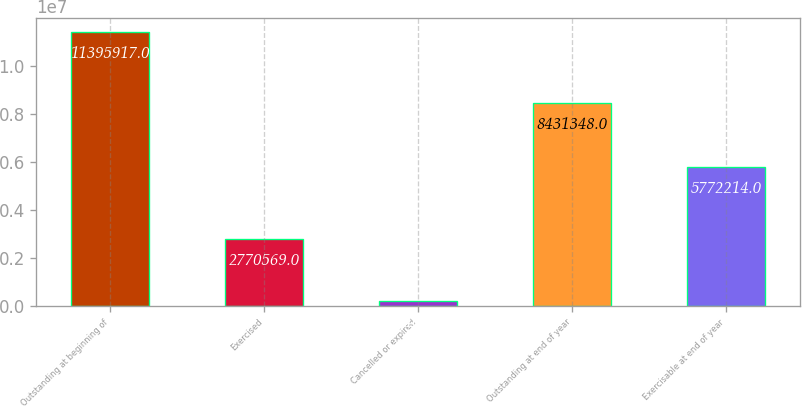<chart> <loc_0><loc_0><loc_500><loc_500><bar_chart><fcel>Outstanding at beginning of<fcel>Exercised<fcel>Cancelled or expired<fcel>Outstanding at end of year<fcel>Exercisable at end of year<nl><fcel>1.13959e+07<fcel>2.77057e+06<fcel>194000<fcel>8.43135e+06<fcel>5.77221e+06<nl></chart> 